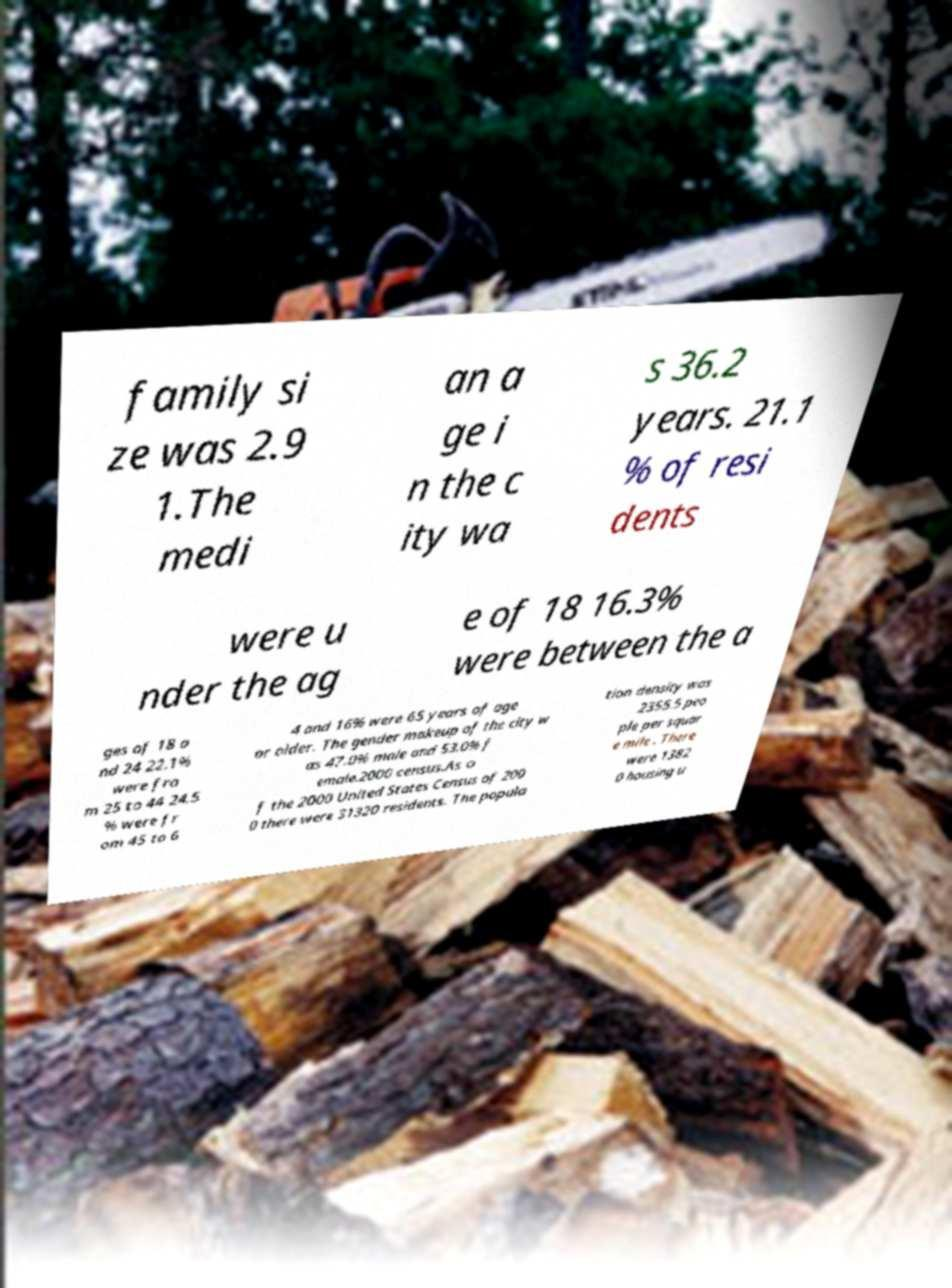Can you accurately transcribe the text from the provided image for me? family si ze was 2.9 1.The medi an a ge i n the c ity wa s 36.2 years. 21.1 % of resi dents were u nder the ag e of 18 16.3% were between the a ges of 18 a nd 24 22.1% were fro m 25 to 44 24.5 % were fr om 45 to 6 4 and 16% were 65 years of age or older. The gender makeup of the city w as 47.0% male and 53.0% f emale.2000 census.As o f the 2000 United States Census of 200 0 there were 31320 residents. The popula tion density was 2355.5 peo ple per squar e mile . There were 1382 0 housing u 